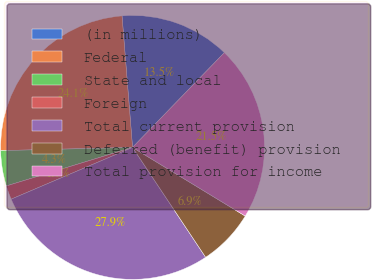Convert chart. <chart><loc_0><loc_0><loc_500><loc_500><pie_chart><fcel>(in millions)<fcel>Federal<fcel>State and local<fcel>Foreign<fcel>Total current provision<fcel>Deferred (benefit) provision<fcel>Total provision for income<nl><fcel>13.52%<fcel>24.12%<fcel>4.33%<fcel>1.7%<fcel>27.93%<fcel>6.95%<fcel>21.46%<nl></chart> 